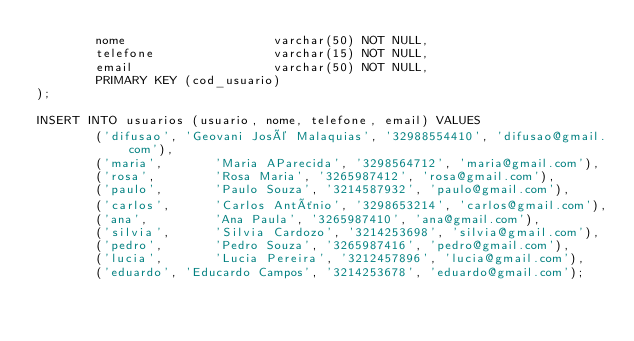Convert code to text. <code><loc_0><loc_0><loc_500><loc_500><_SQL_>        nome                    varchar(50) NOT NULL,
        telefone                varchar(15) NOT NULL,
        email                   varchar(50) NOT NULL,
        PRIMARY KEY (cod_usuario)
);

INSERT INTO usuarios (usuario, nome, telefone, email) VALUES
        ('difusao', 'Geovani José Malaquias', '32988554410', 'difusao@gmail.com'),
        ('maria',       'Maria AParecida', '3298564712', 'maria@gmail.com'),
        ('rosa',        'Rosa Maria', '3265987412', 'rosa@gmail.com'),
        ('paulo',       'Paulo Souza', '3214587932', 'paulo@gmail.com'),
        ('carlos',      'Carlos Antônio', '3298653214', 'carlos@gmail.com'),
        ('ana',         'Ana Paula', '3265987410', 'ana@gmail.com'),
        ('silvia',      'Silvia Cardozo', '3214253698', 'silvia@gmail.com'),
        ('pedro',       'Pedro Souza', '3265987416', 'pedro@gmail.com'),
        ('lucia',       'Lucia Pereira', '3212457896', 'lucia@gmail.com'),
        ('eduardo', 'Educardo Campos', '3214253678', 'eduardo@gmail.com');</code> 